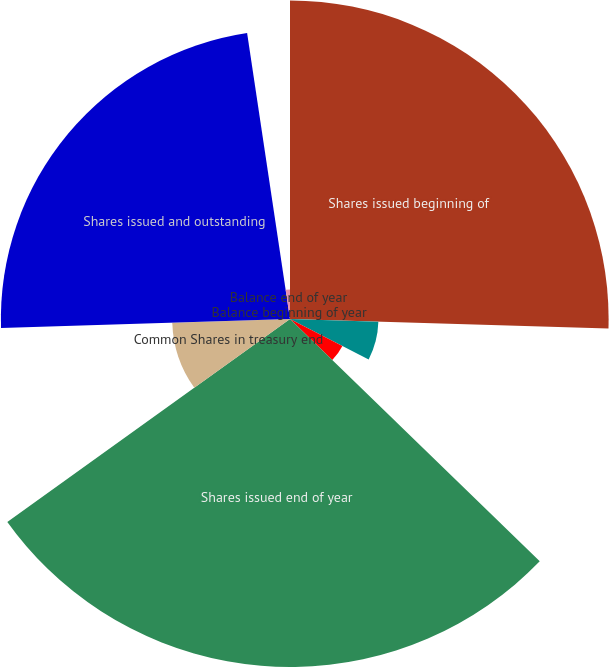Convert chart to OTSL. <chart><loc_0><loc_0><loc_500><loc_500><pie_chart><fcel>Shares issued beginning of<fcel>Shares issued net<fcel>Exercise of stock options<fcel>Shares issued end of year<fcel>Common Shares in treasury end<fcel>Shares issued and outstanding<fcel>Balance beginning of year<fcel>Balance end of year<nl><fcel>25.48%<fcel>7.07%<fcel>4.71%<fcel>27.83%<fcel>9.42%<fcel>23.12%<fcel>0.01%<fcel>2.36%<nl></chart> 